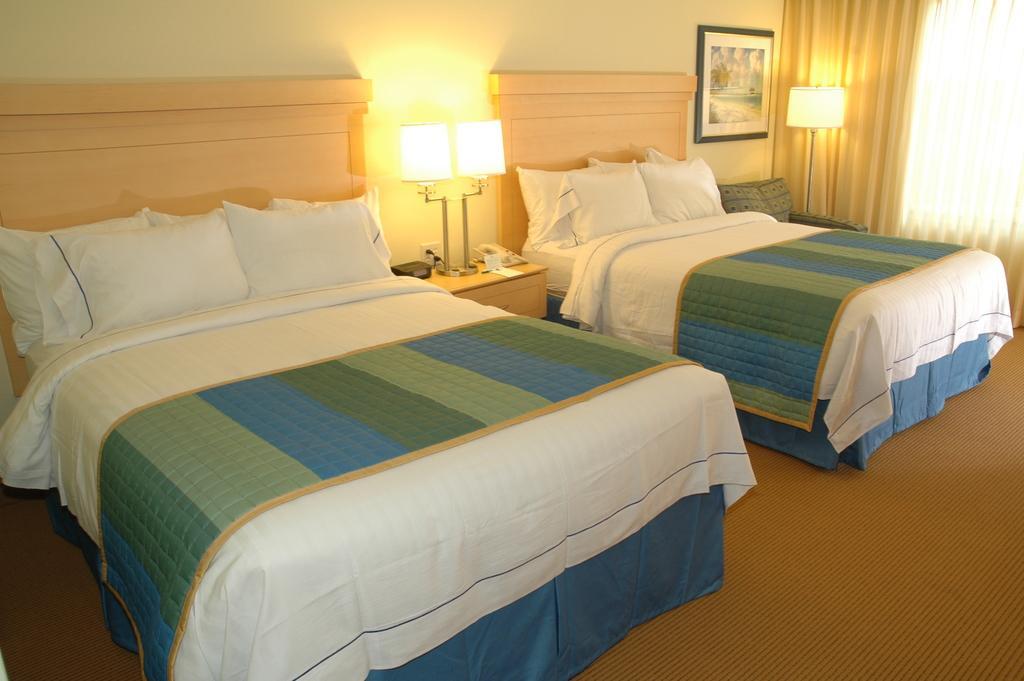In one or two sentences, can you explain what this image depicts? Here we can see beds, pillows and bed-sheet. Beside this beds there are tables, on these tables there are lamps. Picture is on the wall. This is curtain. 